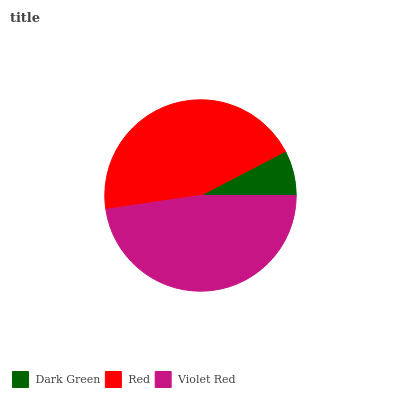Is Dark Green the minimum?
Answer yes or no. Yes. Is Violet Red the maximum?
Answer yes or no. Yes. Is Red the minimum?
Answer yes or no. No. Is Red the maximum?
Answer yes or no. No. Is Red greater than Dark Green?
Answer yes or no. Yes. Is Dark Green less than Red?
Answer yes or no. Yes. Is Dark Green greater than Red?
Answer yes or no. No. Is Red less than Dark Green?
Answer yes or no. No. Is Red the high median?
Answer yes or no. Yes. Is Red the low median?
Answer yes or no. Yes. Is Dark Green the high median?
Answer yes or no. No. Is Violet Red the low median?
Answer yes or no. No. 